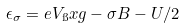<formula> <loc_0><loc_0><loc_500><loc_500>\epsilon _ { \sigma } = e V _ { \i } x { g } - \sigma B - U / 2</formula> 